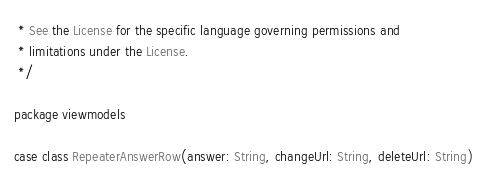<code> <loc_0><loc_0><loc_500><loc_500><_Scala_> * See the License for the specific language governing permissions and
 * limitations under the License.
 */

package viewmodels

case class RepeaterAnswerRow(answer: String, changeUrl: String, deleteUrl: String)
</code> 